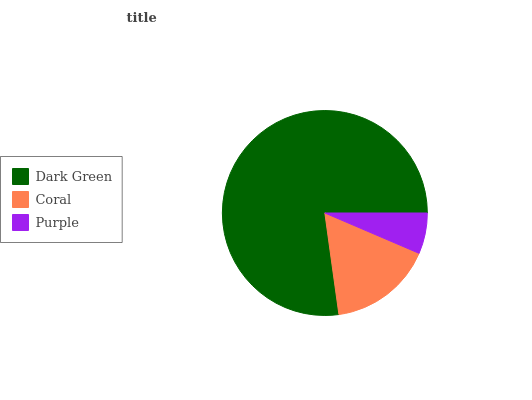Is Purple the minimum?
Answer yes or no. Yes. Is Dark Green the maximum?
Answer yes or no. Yes. Is Coral the minimum?
Answer yes or no. No. Is Coral the maximum?
Answer yes or no. No. Is Dark Green greater than Coral?
Answer yes or no. Yes. Is Coral less than Dark Green?
Answer yes or no. Yes. Is Coral greater than Dark Green?
Answer yes or no. No. Is Dark Green less than Coral?
Answer yes or no. No. Is Coral the high median?
Answer yes or no. Yes. Is Coral the low median?
Answer yes or no. Yes. Is Dark Green the high median?
Answer yes or no. No. Is Purple the low median?
Answer yes or no. No. 